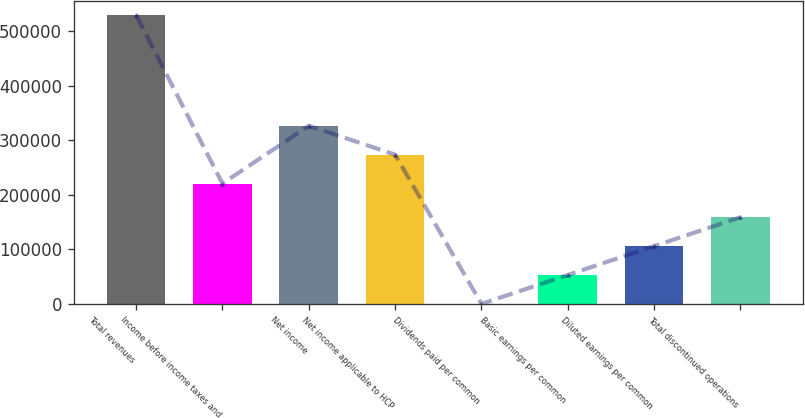Convert chart to OTSL. <chart><loc_0><loc_0><loc_500><loc_500><bar_chart><fcel>Total revenues<fcel>Income before income taxes and<fcel>Net income<fcel>Net income applicable to HCP<fcel>Dividends paid per common<fcel>Basic earnings per common<fcel>Diluted earnings per common<fcel>Total discontinued operations<nl><fcel>529992<fcel>220795<fcel>326793<fcel>273794<fcel>0.55<fcel>52999.7<fcel>105999<fcel>158998<nl></chart> 